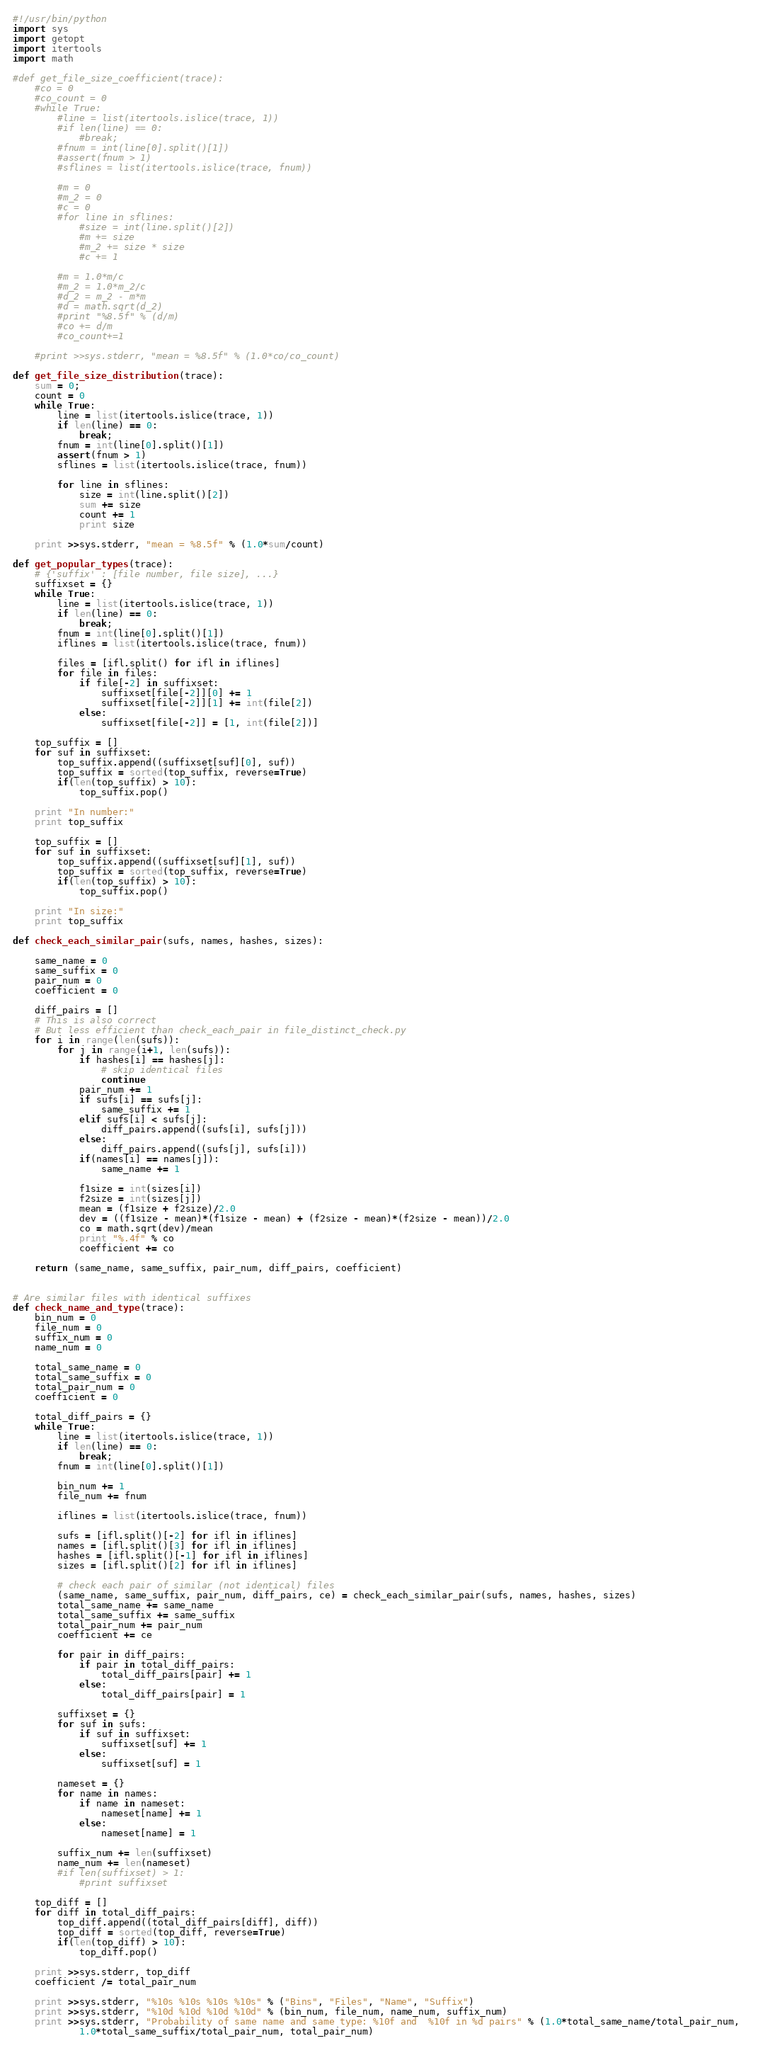<code> <loc_0><loc_0><loc_500><loc_500><_Python_>#!/usr/bin/python
import sys
import getopt
import itertools
import math

#def get_file_size_coefficient(trace):
    #co = 0
    #co_count = 0
    #while True:
        #line = list(itertools.islice(trace, 1))
        #if len(line) == 0:
            #break;
        #fnum = int(line[0].split()[1])
        #assert(fnum > 1)
        #sflines = list(itertools.islice(trace, fnum))

        #m = 0
        #m_2 = 0
        #c = 0
        #for line in sflines:
            #size = int(line.split()[2])
            #m += size
            #m_2 += size * size
            #c += 1

        #m = 1.0*m/c
        #m_2 = 1.0*m_2/c
        #d_2 = m_2 - m*m
        #d = math.sqrt(d_2)
        #print "%8.5f" % (d/m)
        #co += d/m
        #co_count+=1

    #print >>sys.stderr, "mean = %8.5f" % (1.0*co/co_count)

def get_file_size_distribution(trace):
    sum = 0;
    count = 0
    while True:
        line = list(itertools.islice(trace, 1))
        if len(line) == 0:
            break;
        fnum = int(line[0].split()[1])
        assert(fnum > 1)
        sflines = list(itertools.islice(trace, fnum))

        for line in sflines:
            size = int(line.split()[2])
            sum += size
            count += 1
            print size 

    print >>sys.stderr, "mean = %8.5f" % (1.0*sum/count)

def get_popular_types(trace):
    # {'suffix' : [file number, file size], ...}
    suffixset = {}
    while True:
        line = list(itertools.islice(trace, 1))
        if len(line) == 0:
            break;
        fnum = int(line[0].split()[1])
        iflines = list(itertools.islice(trace, fnum))

        files = [ifl.split() for ifl in iflines]
        for file in files: 
            if file[-2] in suffixset:
                suffixset[file[-2]][0] += 1 
                suffixset[file[-2]][1] += int(file[2])
            else:
                suffixset[file[-2]] = [1, int(file[2])]

    top_suffix = []
    for suf in suffixset:
        top_suffix.append((suffixset[suf][0], suf))
        top_suffix = sorted(top_suffix, reverse=True)
        if(len(top_suffix) > 10):
            top_suffix.pop()

    print "In number:"
    print top_suffix

    top_suffix = []
    for suf in suffixset:
        top_suffix.append((suffixset[suf][1], suf))
        top_suffix = sorted(top_suffix, reverse=True)
        if(len(top_suffix) > 10):
            top_suffix.pop()

    print "In size:"
    print top_suffix

def check_each_similar_pair(sufs, names, hashes, sizes):

    same_name = 0
    same_suffix = 0
    pair_num = 0
    coefficient = 0

    diff_pairs = []
    # This is also correct
    # But less efficient than check_each_pair in file_distinct_check.py
    for i in range(len(sufs)):
        for j in range(i+1, len(sufs)):
            if hashes[i] == hashes[j]:
                # skip identical files
                continue
            pair_num += 1
            if sufs[i] == sufs[j]:
                same_suffix += 1
            elif sufs[i] < sufs[j]:
                diff_pairs.append((sufs[i], sufs[j]))
            else:
                diff_pairs.append((sufs[j], sufs[i]))
            if(names[i] == names[j]):
                same_name += 1

            f1size = int(sizes[i])
            f2size = int(sizes[j])
            mean = (f1size + f2size)/2.0
            dev = ((f1size - mean)*(f1size - mean) + (f2size - mean)*(f2size - mean))/2.0
            co = math.sqrt(dev)/mean
            print "%.4f" % co
            coefficient += co 

    return (same_name, same_suffix, pair_num, diff_pairs, coefficient)


# Are similar files with identical suffixes
def check_name_and_type(trace):
    bin_num = 0
    file_num = 0
    suffix_num = 0
    name_num = 0

    total_same_name = 0
    total_same_suffix = 0
    total_pair_num = 0
    coefficient = 0

    total_diff_pairs = {}
    while True:
        line = list(itertools.islice(trace, 1))
        if len(line) == 0:
            break;
        fnum = int(line[0].split()[1])

        bin_num += 1
        file_num += fnum

        iflines = list(itertools.islice(trace, fnum))

        sufs = [ifl.split()[-2] for ifl in iflines]
        names = [ifl.split()[3] for ifl in iflines]
        hashes = [ifl.split()[-1] for ifl in iflines]
        sizes = [ifl.split()[2] for ifl in iflines]

        # check each pair of similar (not identical) files
        (same_name, same_suffix, pair_num, diff_pairs, ce) = check_each_similar_pair(sufs, names, hashes, sizes)
        total_same_name += same_name
        total_same_suffix += same_suffix
        total_pair_num += pair_num
        coefficient += ce

        for pair in diff_pairs:
            if pair in total_diff_pairs:
                total_diff_pairs[pair] += 1
            else:
                total_diff_pairs[pair] = 1

        suffixset = {}
        for suf in sufs:
            if suf in suffixset:
                suffixset[suf] += 1
            else:
                suffixset[suf] = 1

        nameset = {}
        for name in names:
            if name in nameset:
                nameset[name] += 1
            else:
                nameset[name] = 1

        suffix_num += len(suffixset)
        name_num += len(nameset)
        #if len(suffixset) > 1:
            #print suffixset

    top_diff = []
    for diff in total_diff_pairs:
        top_diff.append((total_diff_pairs[diff], diff))
        top_diff = sorted(top_diff, reverse=True)
        if(len(top_diff) > 10):
            top_diff.pop()

    print >>sys.stderr, top_diff
    coefficient /= total_pair_num

    print >>sys.stderr, "%10s %10s %10s %10s" % ("Bins", "Files", "Name", "Suffix")
    print >>sys.stderr, "%10d %10d %10d %10d" % (bin_num, file_num, name_num, suffix_num)
    print >>sys.stderr, "Probability of same name and same type: %10f and  %10f in %d pairs" % (1.0*total_same_name/total_pair_num, 
            1.0*total_same_suffix/total_pair_num, total_pair_num)</code> 